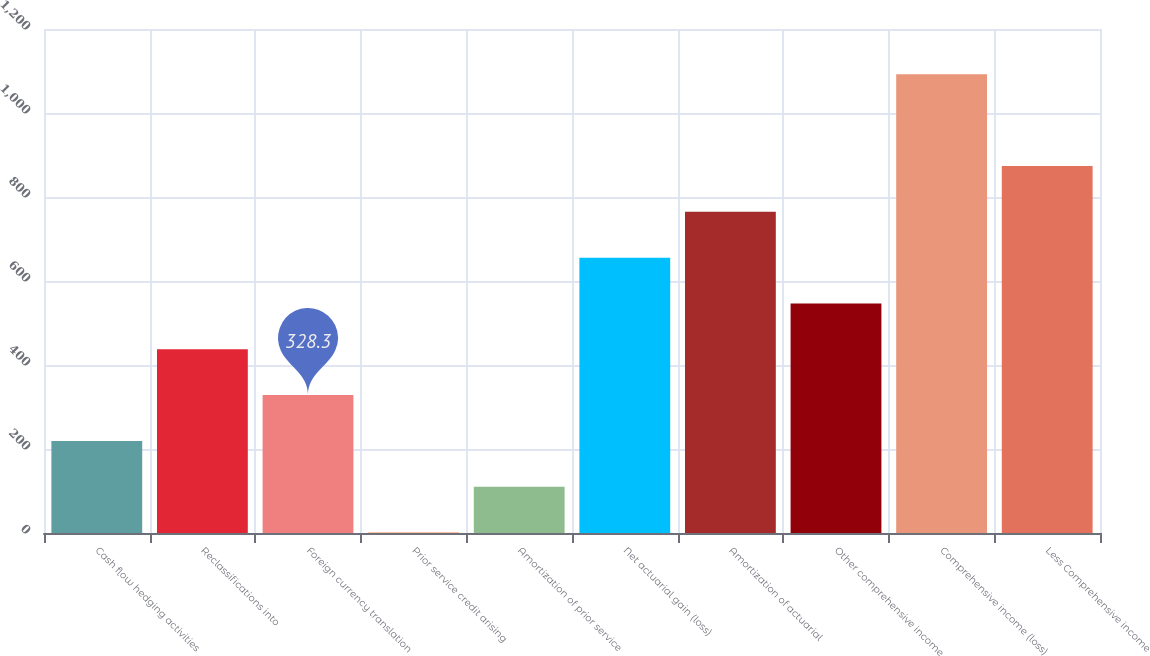<chart> <loc_0><loc_0><loc_500><loc_500><bar_chart><fcel>Cash flow hedging activities<fcel>Reclassifications into<fcel>Foreign currency translation<fcel>Prior service credit arising<fcel>Amortization of prior service<fcel>Net actuarial gain (loss)<fcel>Amortization of actuarial<fcel>Other comprehensive income<fcel>Comprehensive income (loss)<fcel>Less Comprehensive income<nl><fcel>219.2<fcel>437.4<fcel>328.3<fcel>1<fcel>110.1<fcel>655.6<fcel>764.7<fcel>546.5<fcel>1092<fcel>873.8<nl></chart> 